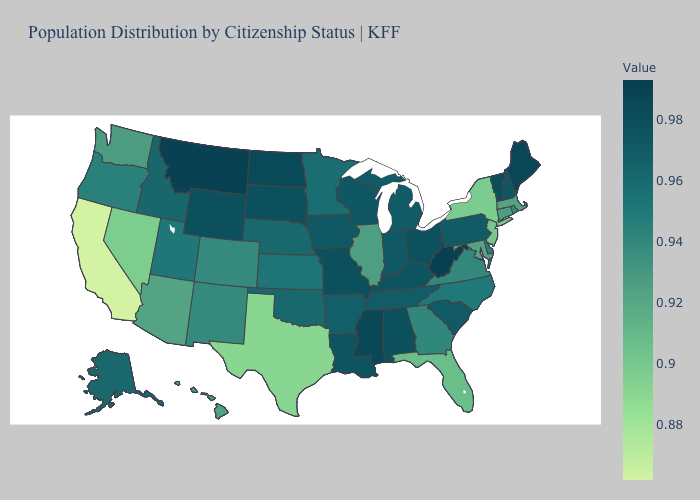Which states have the highest value in the USA?
Answer briefly. West Virginia. Does New York have the highest value in the USA?
Concise answer only. No. Among the states that border Iowa , which have the lowest value?
Concise answer only. Illinois. Does New Mexico have the highest value in the West?
Quick response, please. No. Which states have the lowest value in the West?
Concise answer only. California. Among the states that border Indiana , does Ohio have the highest value?
Keep it brief. Yes. Does West Virginia have the highest value in the South?
Quick response, please. Yes. 